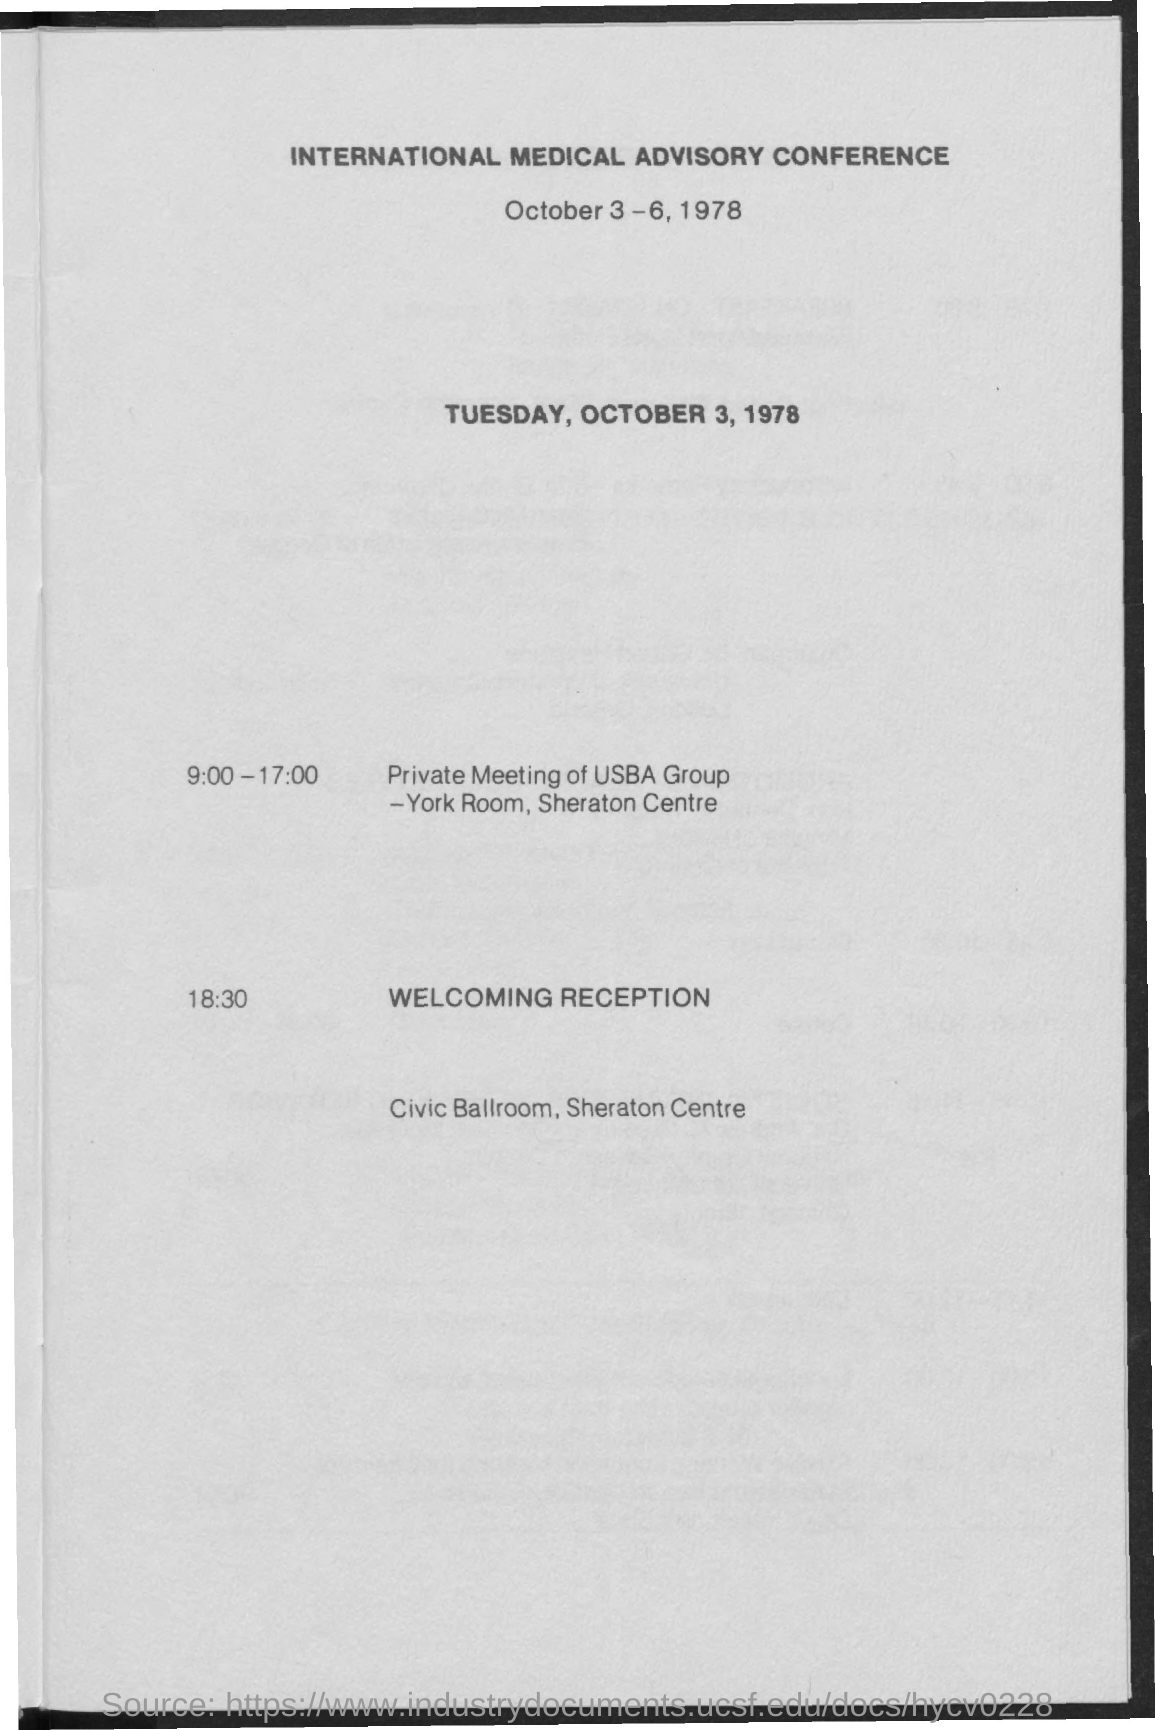Identify some key points in this picture. The conference is going to be held from October 3rd to October 6th, 1978. The International Medical Advisory Conference is about. From 9:00 a.m. to 5:00 p.m., there was a private meeting of the USBA group. The welcoming reception will be held in CIVIC BALLROOM at the SHERATON CENTRE. 